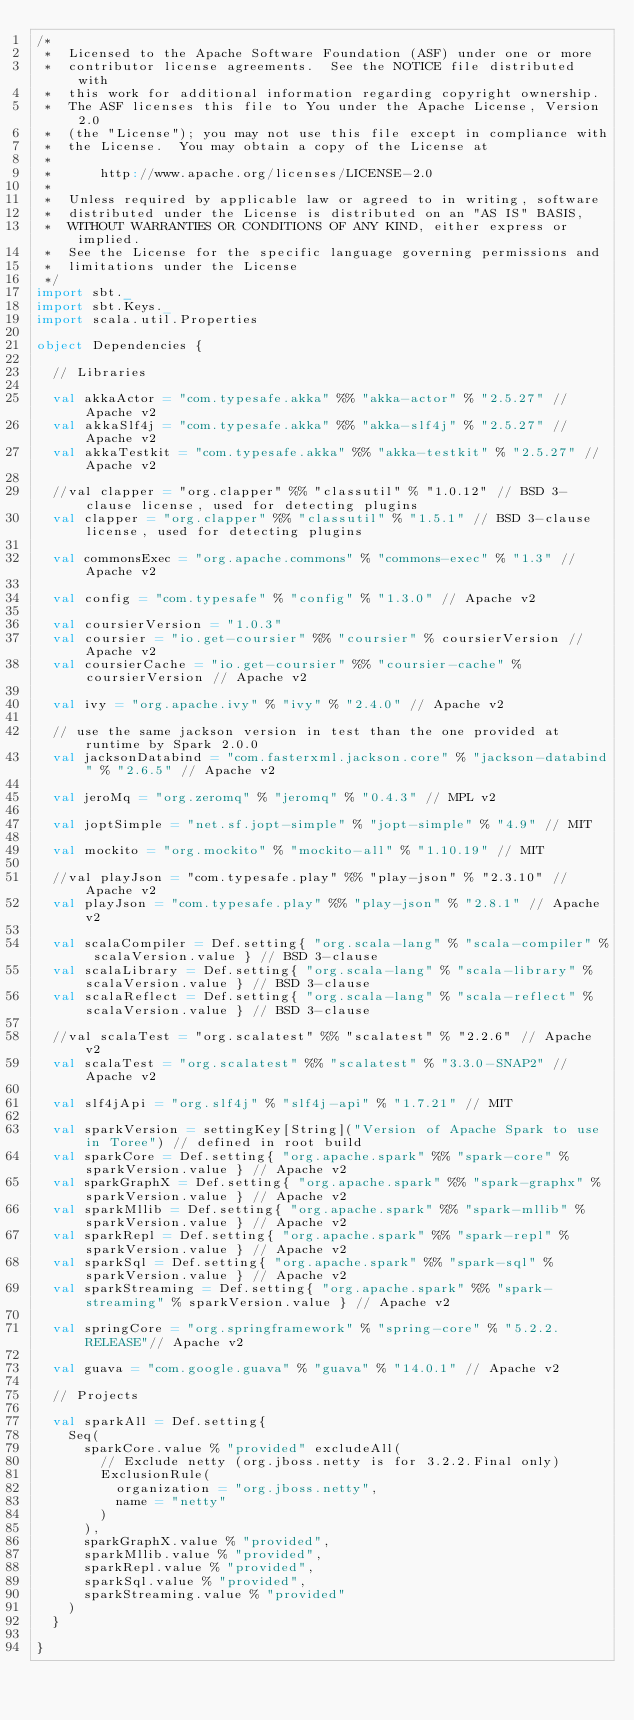<code> <loc_0><loc_0><loc_500><loc_500><_Scala_>/*
 *  Licensed to the Apache Software Foundation (ASF) under one or more
 *  contributor license agreements.  See the NOTICE file distributed with
 *  this work for additional information regarding copyright ownership.
 *  The ASF licenses this file to You under the Apache License, Version 2.0
 *  (the "License"); you may not use this file except in compliance with
 *  the License.  You may obtain a copy of the License at
 *
 *      http://www.apache.org/licenses/LICENSE-2.0
 *
 *  Unless required by applicable law or agreed to in writing, software
 *  distributed under the License is distributed on an "AS IS" BASIS,
 *  WITHOUT WARRANTIES OR CONDITIONS OF ANY KIND, either express or implied.
 *  See the License for the specific language governing permissions and
 *  limitations under the License
 */
import sbt._
import sbt.Keys._
import scala.util.Properties

object Dependencies {

  // Libraries

  val akkaActor = "com.typesafe.akka" %% "akka-actor" % "2.5.27" // Apache v2
  val akkaSlf4j = "com.typesafe.akka" %% "akka-slf4j" % "2.5.27" // Apache v2
  val akkaTestkit = "com.typesafe.akka" %% "akka-testkit" % "2.5.27" // Apache v2

  //val clapper = "org.clapper" %% "classutil" % "1.0.12" // BSD 3-clause license, used for detecting plugins
  val clapper = "org.clapper" %% "classutil" % "1.5.1" // BSD 3-clause license, used for detecting plugins

  val commonsExec = "org.apache.commons" % "commons-exec" % "1.3" // Apache v2

  val config = "com.typesafe" % "config" % "1.3.0" // Apache v2

  val coursierVersion = "1.0.3"
  val coursier = "io.get-coursier" %% "coursier" % coursierVersion // Apache v2
  val coursierCache = "io.get-coursier" %% "coursier-cache" % coursierVersion // Apache v2

  val ivy = "org.apache.ivy" % "ivy" % "2.4.0" // Apache v2

  // use the same jackson version in test than the one provided at runtime by Spark 2.0.0
  val jacksonDatabind = "com.fasterxml.jackson.core" % "jackson-databind" % "2.6.5" // Apache v2

  val jeroMq = "org.zeromq" % "jeromq" % "0.4.3" // MPL v2

  val joptSimple = "net.sf.jopt-simple" % "jopt-simple" % "4.9" // MIT

  val mockito = "org.mockito" % "mockito-all" % "1.10.19" // MIT

  //val playJson = "com.typesafe.play" %% "play-json" % "2.3.10" // Apache v2
  val playJson = "com.typesafe.play" %% "play-json" % "2.8.1" // Apache v2

  val scalaCompiler = Def.setting{ "org.scala-lang" % "scala-compiler" % scalaVersion.value } // BSD 3-clause
  val scalaLibrary = Def.setting{ "org.scala-lang" % "scala-library" % scalaVersion.value } // BSD 3-clause
  val scalaReflect = Def.setting{ "org.scala-lang" % "scala-reflect" % scalaVersion.value } // BSD 3-clause

  //val scalaTest = "org.scalatest" %% "scalatest" % "2.2.6" // Apache v2
  val scalaTest = "org.scalatest" %% "scalatest" % "3.3.0-SNAP2" // Apache v2

  val slf4jApi = "org.slf4j" % "slf4j-api" % "1.7.21" // MIT

  val sparkVersion = settingKey[String]("Version of Apache Spark to use in Toree") // defined in root build
  val sparkCore = Def.setting{ "org.apache.spark" %% "spark-core" % sparkVersion.value } // Apache v2
  val sparkGraphX = Def.setting{ "org.apache.spark" %% "spark-graphx" % sparkVersion.value } // Apache v2
  val sparkMllib = Def.setting{ "org.apache.spark" %% "spark-mllib" % sparkVersion.value } // Apache v2
  val sparkRepl = Def.setting{ "org.apache.spark" %% "spark-repl" % sparkVersion.value } // Apache v2
  val sparkSql = Def.setting{ "org.apache.spark" %% "spark-sql" % sparkVersion.value } // Apache v2
  val sparkStreaming = Def.setting{ "org.apache.spark" %% "spark-streaming" % sparkVersion.value } // Apache v2

  val springCore = "org.springframework" % "spring-core" % "5.2.2.RELEASE"// Apache v2

  val guava = "com.google.guava" % "guava" % "14.0.1" // Apache v2

  // Projects

  val sparkAll = Def.setting{
    Seq(
      sparkCore.value % "provided" excludeAll(
        // Exclude netty (org.jboss.netty is for 3.2.2.Final only)
        ExclusionRule(
          organization = "org.jboss.netty",
          name = "netty"
        )
      ),
      sparkGraphX.value % "provided",
      sparkMllib.value % "provided",
      sparkRepl.value % "provided",
      sparkSql.value % "provided",
      sparkStreaming.value % "provided"
    )
  }

}
</code> 